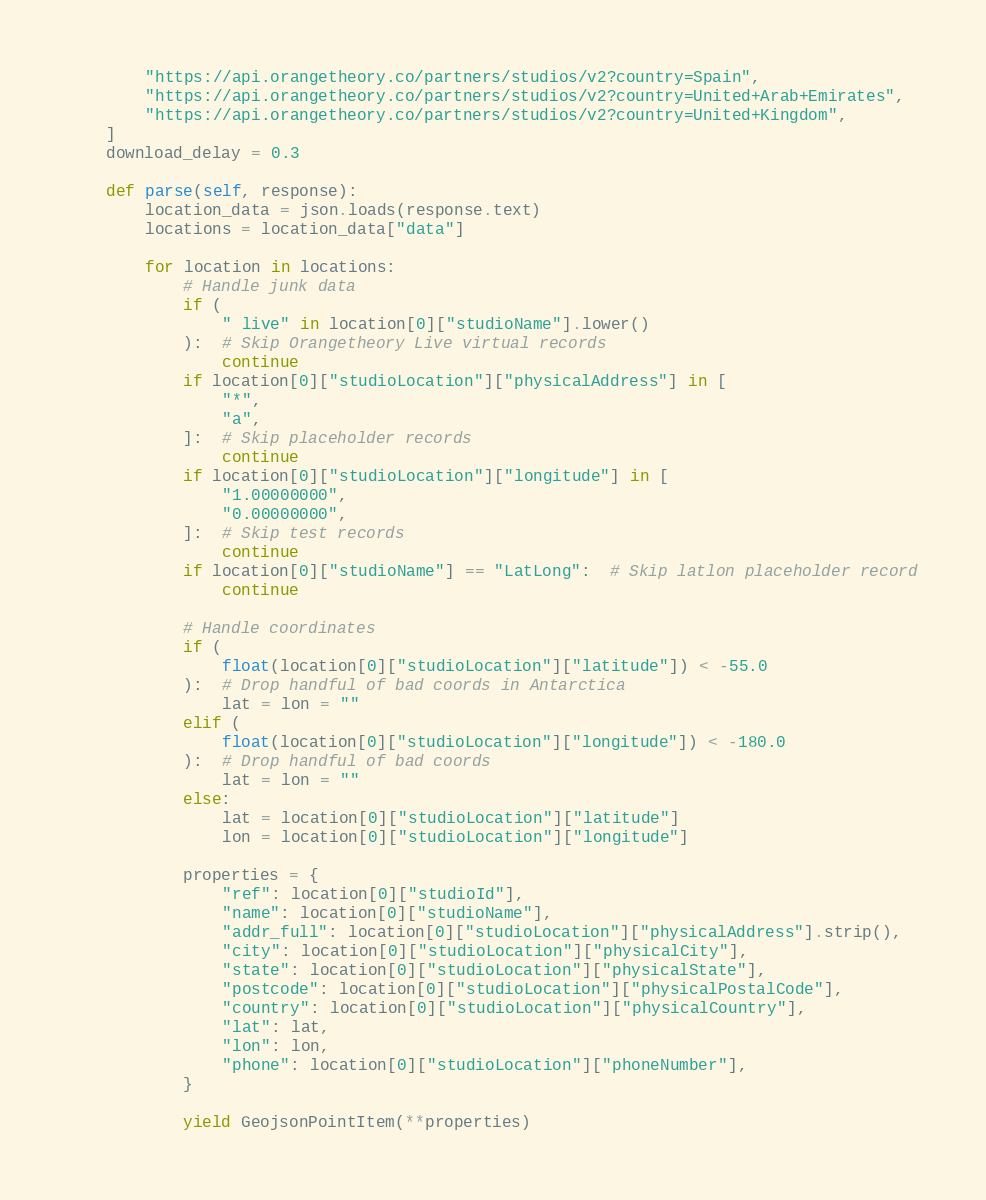<code> <loc_0><loc_0><loc_500><loc_500><_Python_>        "https://api.orangetheory.co/partners/studios/v2?country=Spain",
        "https://api.orangetheory.co/partners/studios/v2?country=United+Arab+Emirates",
        "https://api.orangetheory.co/partners/studios/v2?country=United+Kingdom",
    ]
    download_delay = 0.3

    def parse(self, response):
        location_data = json.loads(response.text)
        locations = location_data["data"]

        for location in locations:
            # Handle junk data
            if (
                " live" in location[0]["studioName"].lower()
            ):  # Skip Orangetheory Live virtual records
                continue
            if location[0]["studioLocation"]["physicalAddress"] in [
                "*",
                "a",
            ]:  # Skip placeholder records
                continue
            if location[0]["studioLocation"]["longitude"] in [
                "1.00000000",
                "0.00000000",
            ]:  # Skip test records
                continue
            if location[0]["studioName"] == "LatLong":  # Skip latlon placeholder record
                continue

            # Handle coordinates
            if (
                float(location[0]["studioLocation"]["latitude"]) < -55.0
            ):  # Drop handful of bad coords in Antarctica
                lat = lon = ""
            elif (
                float(location[0]["studioLocation"]["longitude"]) < -180.0
            ):  # Drop handful of bad coords
                lat = lon = ""
            else:
                lat = location[0]["studioLocation"]["latitude"]
                lon = location[0]["studioLocation"]["longitude"]

            properties = {
                "ref": location[0]["studioId"],
                "name": location[0]["studioName"],
                "addr_full": location[0]["studioLocation"]["physicalAddress"].strip(),
                "city": location[0]["studioLocation"]["physicalCity"],
                "state": location[0]["studioLocation"]["physicalState"],
                "postcode": location[0]["studioLocation"]["physicalPostalCode"],
                "country": location[0]["studioLocation"]["physicalCountry"],
                "lat": lat,
                "lon": lon,
                "phone": location[0]["studioLocation"]["phoneNumber"],
            }

            yield GeojsonPointItem(**properties)
</code> 